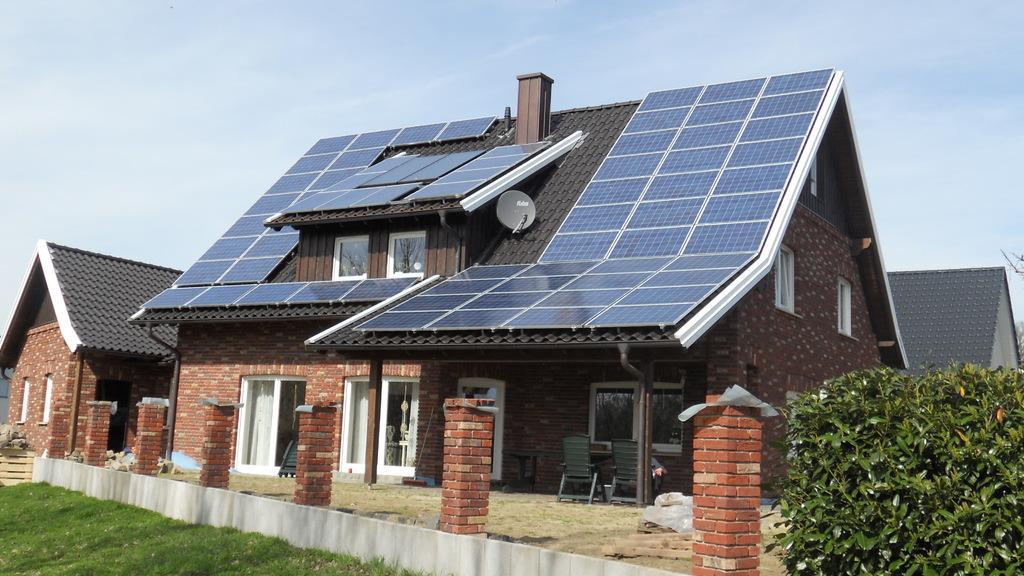Describe this image in one or two sentences. In this picture we can see houses with windows, pipes, chairs, grass, solar panels, trees and in the background we can see the sky with clouds. 